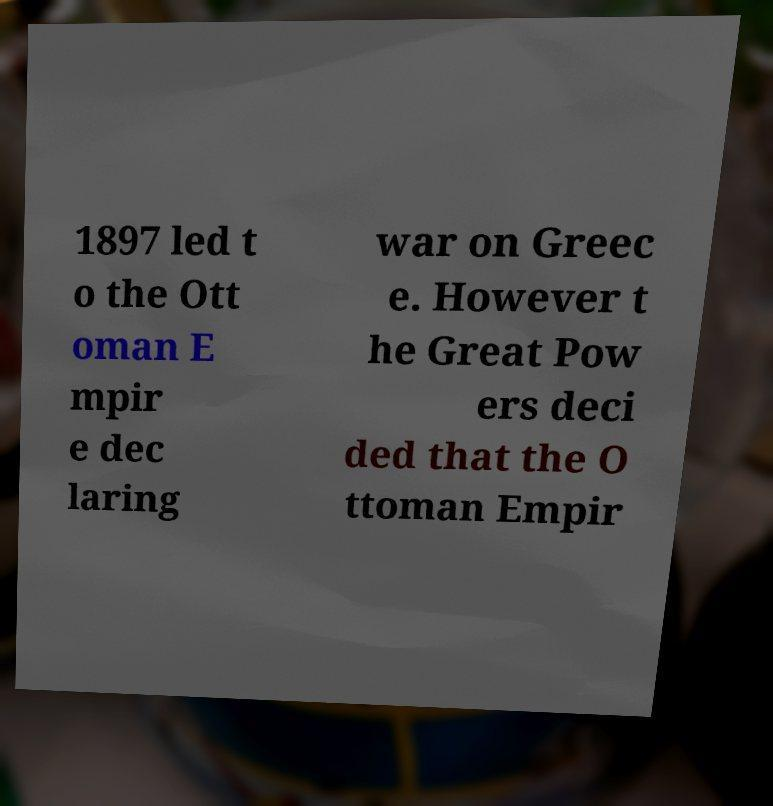For documentation purposes, I need the text within this image transcribed. Could you provide that? 1897 led t o the Ott oman E mpir e dec laring war on Greec e. However t he Great Pow ers deci ded that the O ttoman Empir 